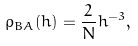<formula> <loc_0><loc_0><loc_500><loc_500>\rho _ { B A } ( h ) = \frac { 2 } { N } h ^ { - 3 } ,</formula> 